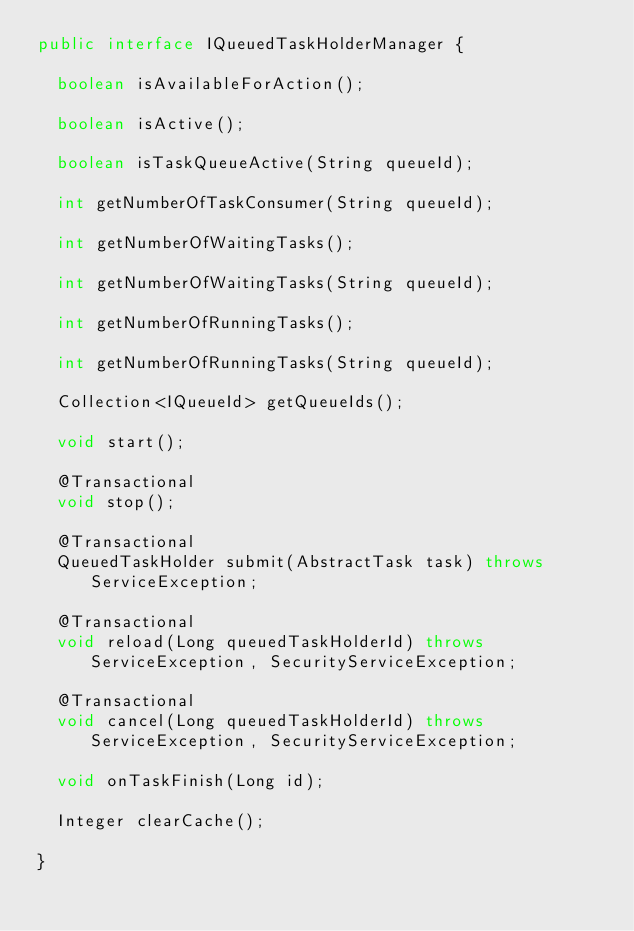Convert code to text. <code><loc_0><loc_0><loc_500><loc_500><_Java_>public interface IQueuedTaskHolderManager {
	
	boolean isAvailableForAction();

	boolean isActive();

	boolean isTaskQueueActive(String queueId);

	int getNumberOfTaskConsumer(String queueId);

	int getNumberOfWaitingTasks();

	int getNumberOfWaitingTasks(String queueId);

	int getNumberOfRunningTasks();

	int getNumberOfRunningTasks(String queueId);

	Collection<IQueueId> getQueueIds();

	void start();

	@Transactional
	void stop();

	@Transactional
	QueuedTaskHolder submit(AbstractTask task) throws ServiceException;

	@Transactional
	void reload(Long queuedTaskHolderId) throws ServiceException, SecurityServiceException;

	@Transactional
	void cancel(Long queuedTaskHolderId) throws ServiceException, SecurityServiceException;

	void onTaskFinish(Long id);
	
	Integer clearCache();

}
</code> 